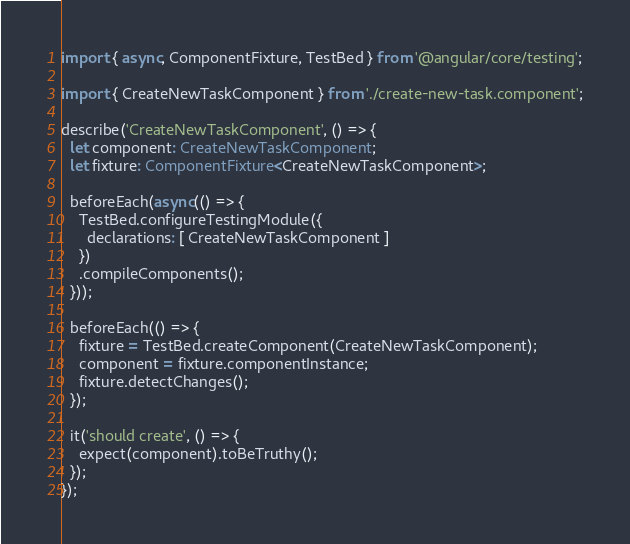Convert code to text. <code><loc_0><loc_0><loc_500><loc_500><_TypeScript_>import { async, ComponentFixture, TestBed } from '@angular/core/testing';

import { CreateNewTaskComponent } from './create-new-task.component';

describe('CreateNewTaskComponent', () => {
  let component: CreateNewTaskComponent;
  let fixture: ComponentFixture<CreateNewTaskComponent>;

  beforeEach(async(() => {
    TestBed.configureTestingModule({
      declarations: [ CreateNewTaskComponent ]
    })
    .compileComponents();
  }));

  beforeEach(() => {
    fixture = TestBed.createComponent(CreateNewTaskComponent);
    component = fixture.componentInstance;
    fixture.detectChanges();
  });

  it('should create', () => {
    expect(component).toBeTruthy();
  });
});
</code> 